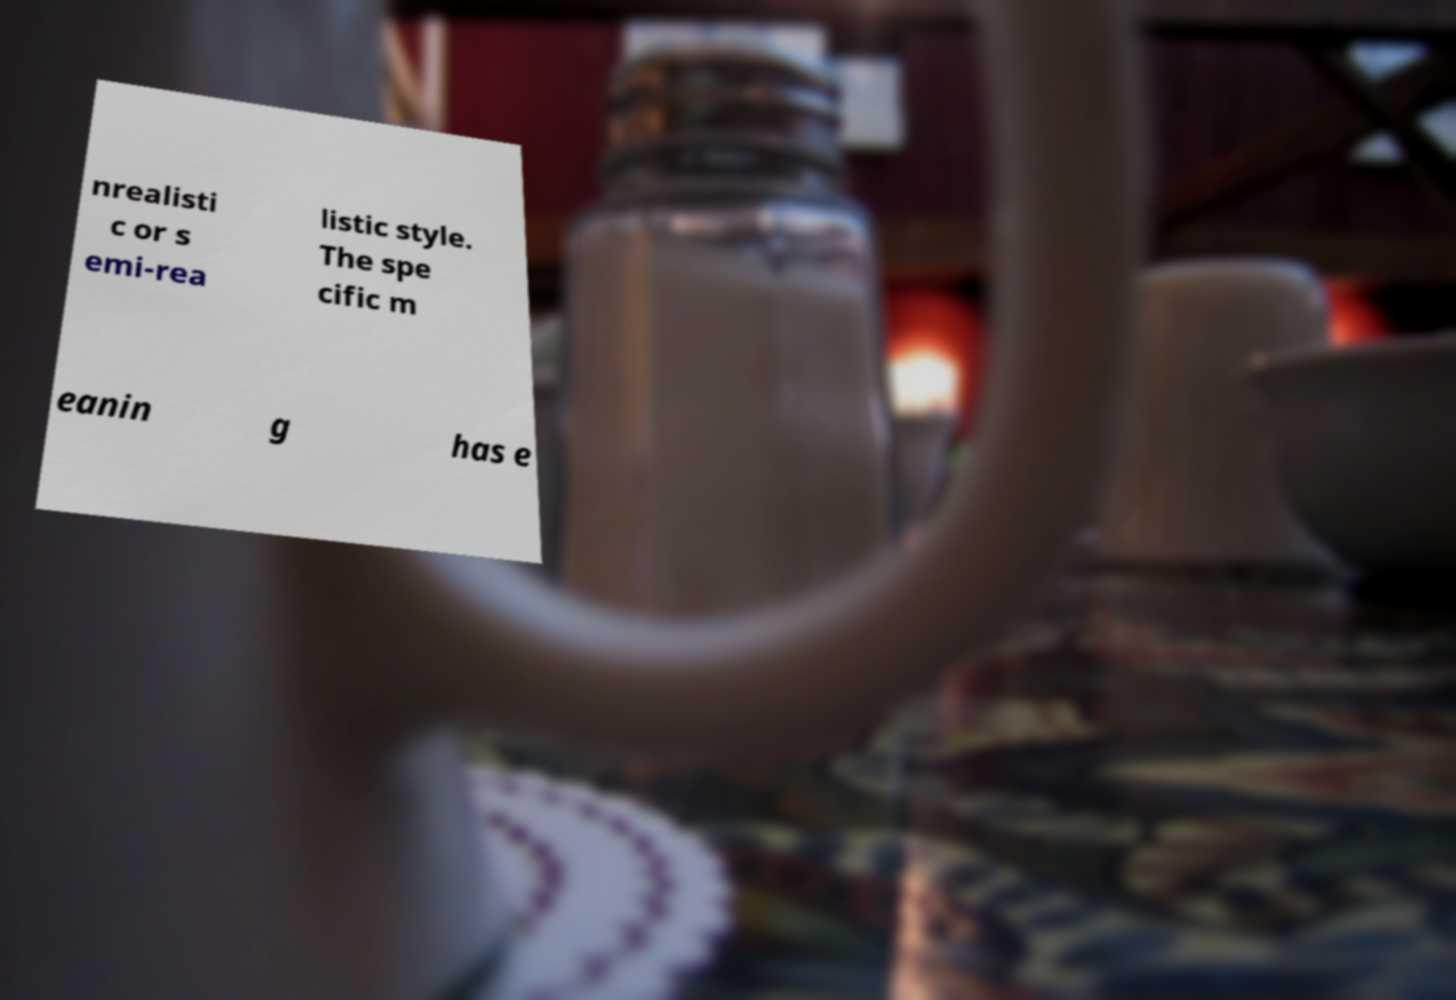Please read and relay the text visible in this image. What does it say? nrealisti c or s emi-rea listic style. The spe cific m eanin g has e 